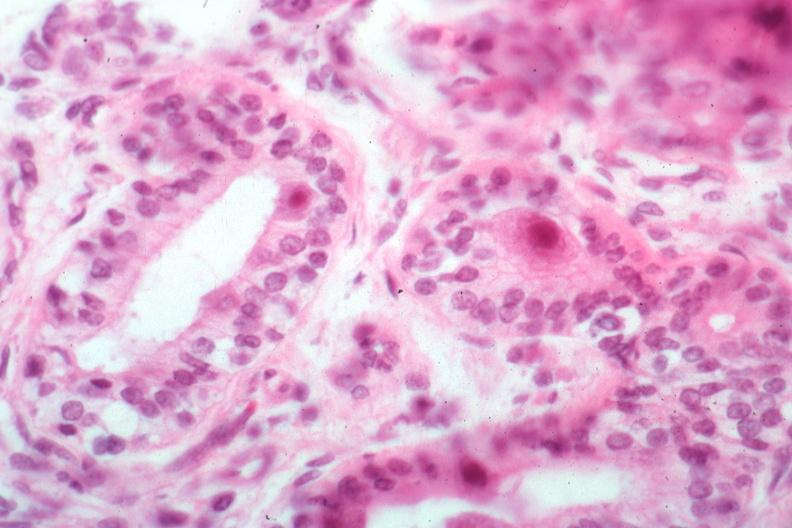s sac present?
Answer the question using a single word or phrase. No 